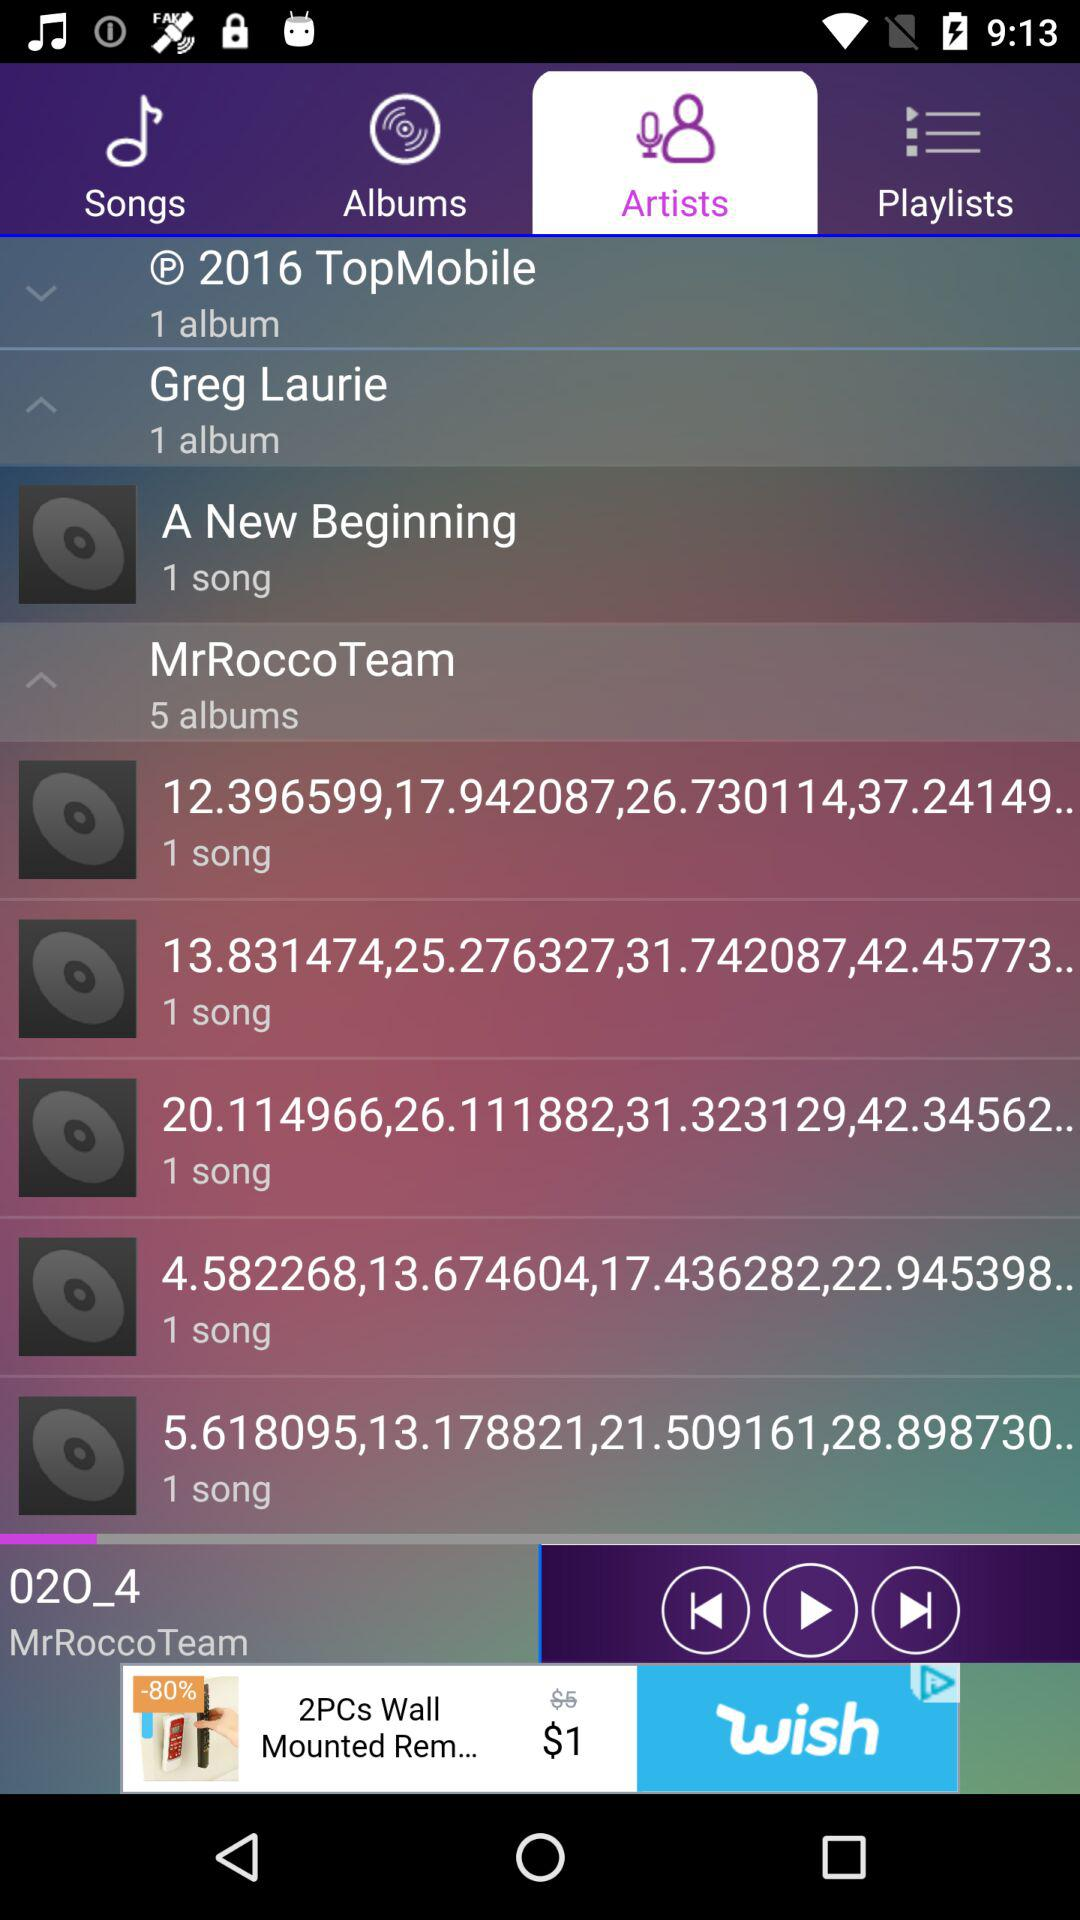How many albums are there for MrRocco Team?
Answer the question using a single word or phrase. 5 